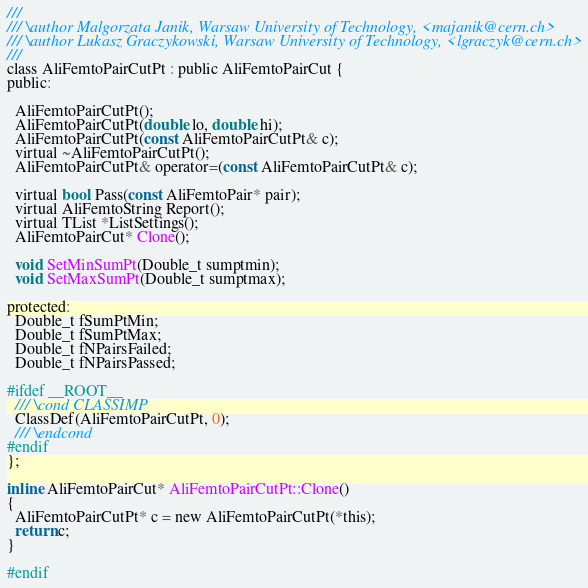<code> <loc_0><loc_0><loc_500><loc_500><_C_>///
/// \author Malgorzata Janik, Warsaw University of Technology, <majanik@cern.ch>
/// \author Lukasz Graczykowski, Warsaw University of Technology, <lgraczyk@cern.ch>
///
class AliFemtoPairCutPt : public AliFemtoPairCut {
public:

  AliFemtoPairCutPt();
  AliFemtoPairCutPt(double lo, double hi);
  AliFemtoPairCutPt(const AliFemtoPairCutPt& c);
  virtual ~AliFemtoPairCutPt();
  AliFemtoPairCutPt& operator=(const AliFemtoPairCutPt& c);

  virtual bool Pass(const AliFemtoPair* pair);
  virtual AliFemtoString Report();
  virtual TList *ListSettings();
  AliFemtoPairCut* Clone();

  void SetMinSumPt(Double_t sumptmin);
  void SetMaxSumPt(Double_t sumptmax);

protected:
  Double_t fSumPtMin;
  Double_t fSumPtMax;
  Double_t fNPairsFailed;
  Double_t fNPairsPassed;

#ifdef __ROOT__
  /// \cond CLASSIMP
  ClassDef(AliFemtoPairCutPt, 0);
  /// \endcond
#endif
};

inline AliFemtoPairCut* AliFemtoPairCutPt::Clone()
{
  AliFemtoPairCutPt* c = new AliFemtoPairCutPt(*this);
  return c;
}

#endif
</code> 